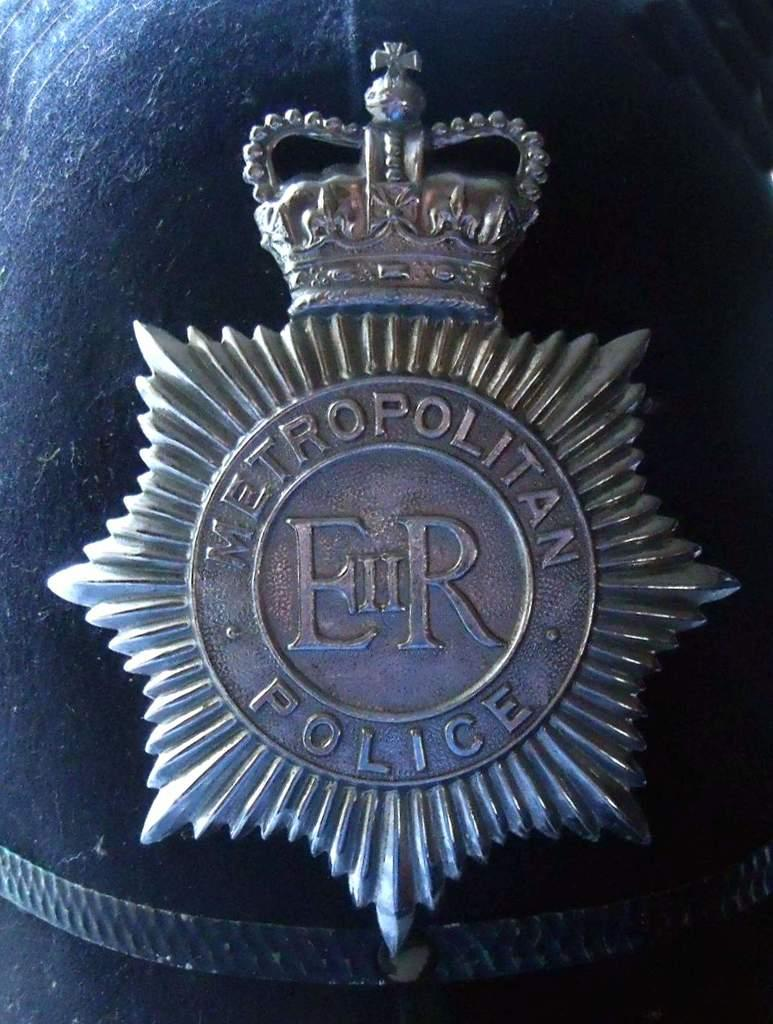<image>
Relay a brief, clear account of the picture shown. the word police is on the front of a round emblem 